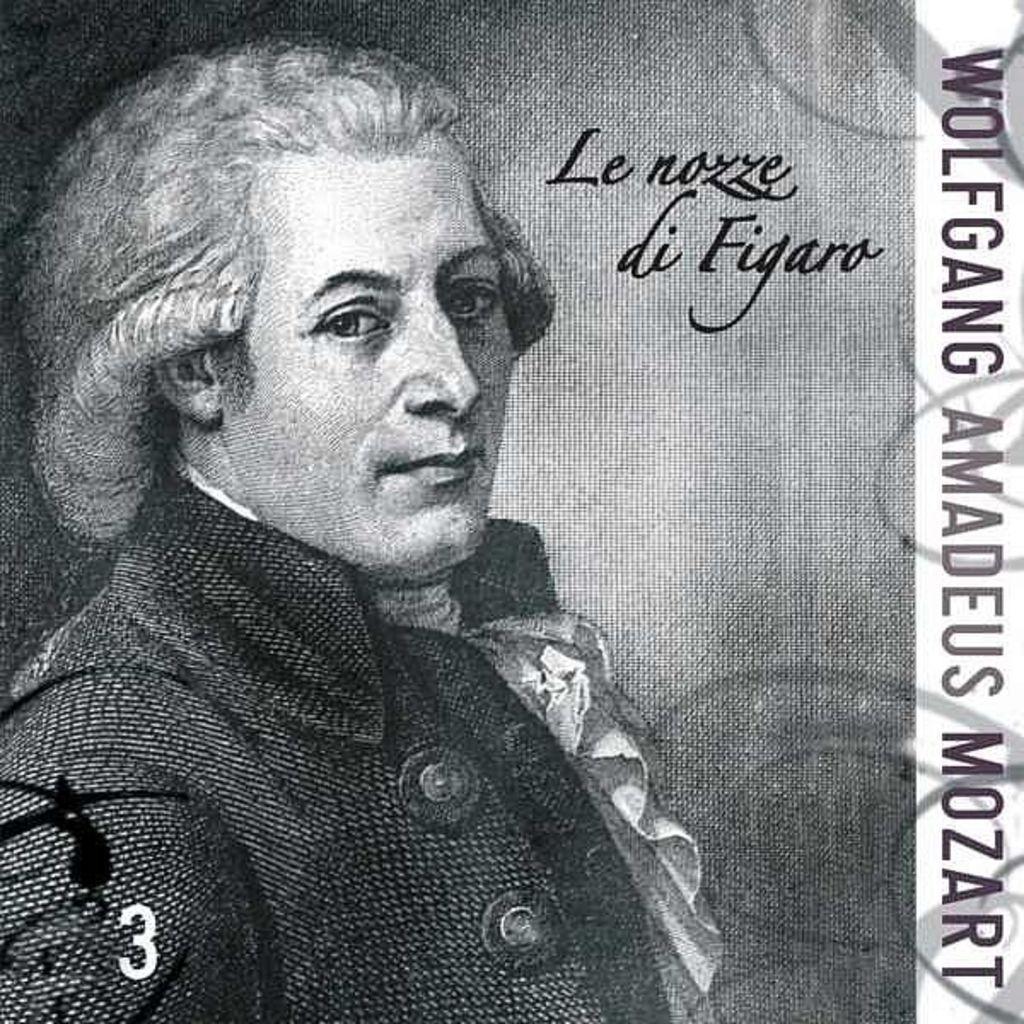Could you give a brief overview of what you see in this image? As we can see in the image there is a banner. On banner there is a man wearing black color jacket and the image is in black and white. 